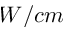Convert formula to latex. <formula><loc_0><loc_0><loc_500><loc_500>W / c m</formula> 